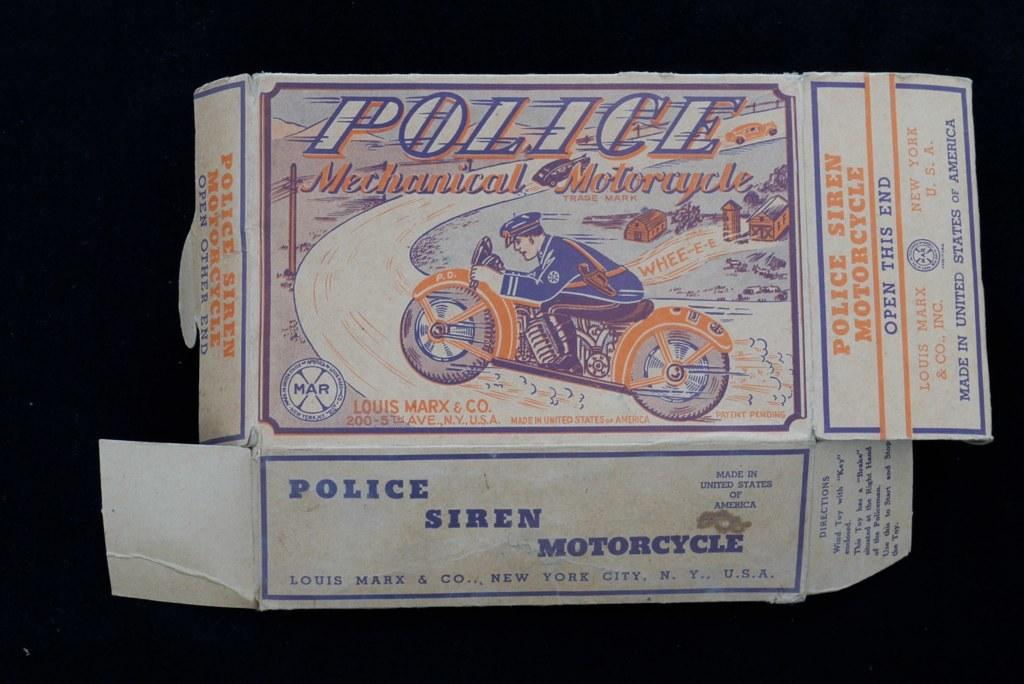What object is present in the image that is typically used for storage or packaging? There is a box in the image. Can you describe any text that is visible on the box? Yes, there is text visible on the box. What mode of transportation is featured in the image? There is a person riding a motorcycle in the image. What type of bushes can be seen growing near the motorcycle in the image? There are no bushes present in the image. How does the balloon affect the speed of the motorcycle in the image? There is no balloon present in the image, so it cannot affect the speed of the motorcycle. Is there a stream visible in the background of the image? There is no stream visible in the image. 